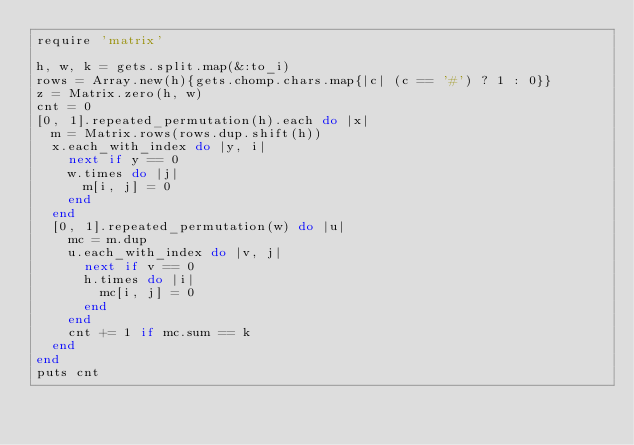<code> <loc_0><loc_0><loc_500><loc_500><_Ruby_>require 'matrix'

h, w, k = gets.split.map(&:to_i)
rows = Array.new(h){gets.chomp.chars.map{|c| (c == '#') ? 1 : 0}}
z = Matrix.zero(h, w)
cnt = 0
[0, 1].repeated_permutation(h).each do |x|
  m = Matrix.rows(rows.dup.shift(h))
  x.each_with_index do |y, i|
    next if y == 0
    w.times do |j|
      m[i, j] = 0
    end
  end
  [0, 1].repeated_permutation(w) do |u|
    mc = m.dup
    u.each_with_index do |v, j|
      next if v == 0
      h.times do |i|
        mc[i, j] = 0
      end
    end
    cnt += 1 if mc.sum == k
  end
end
puts cnt</code> 